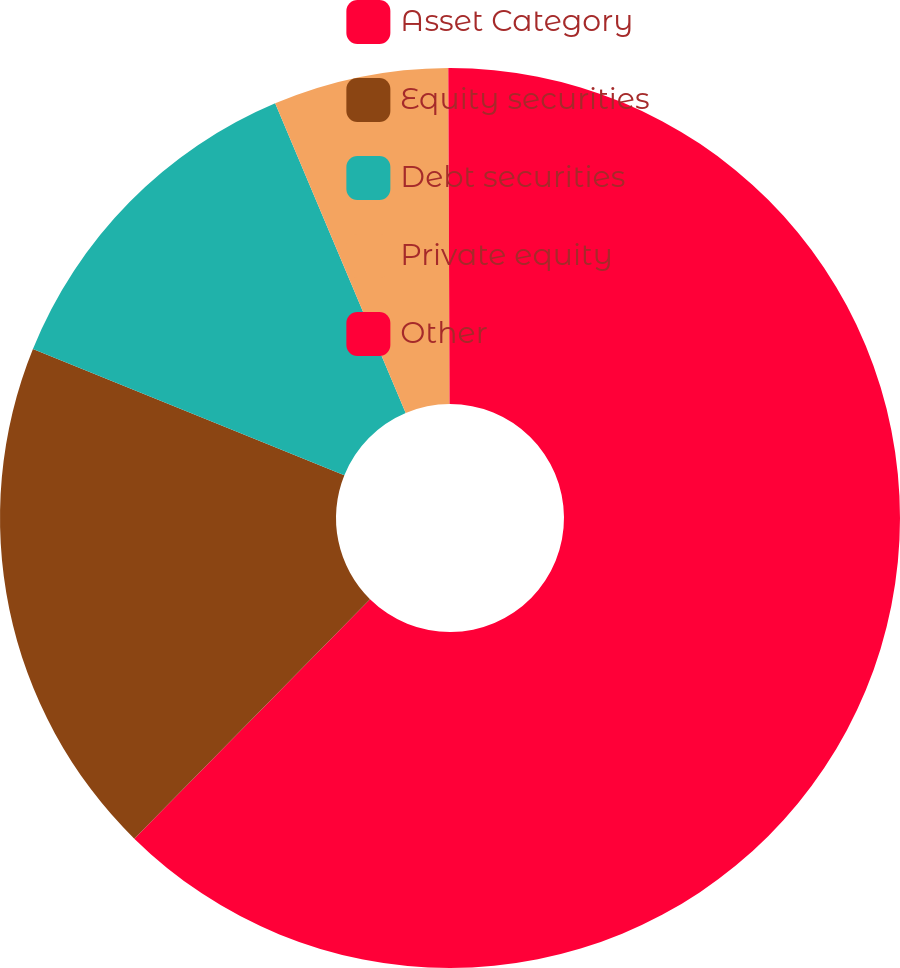Convert chart to OTSL. <chart><loc_0><loc_0><loc_500><loc_500><pie_chart><fcel>Asset Category<fcel>Equity securities<fcel>Debt securities<fcel>Private equity<fcel>Other<nl><fcel>62.37%<fcel>18.75%<fcel>12.52%<fcel>6.29%<fcel>0.06%<nl></chart> 